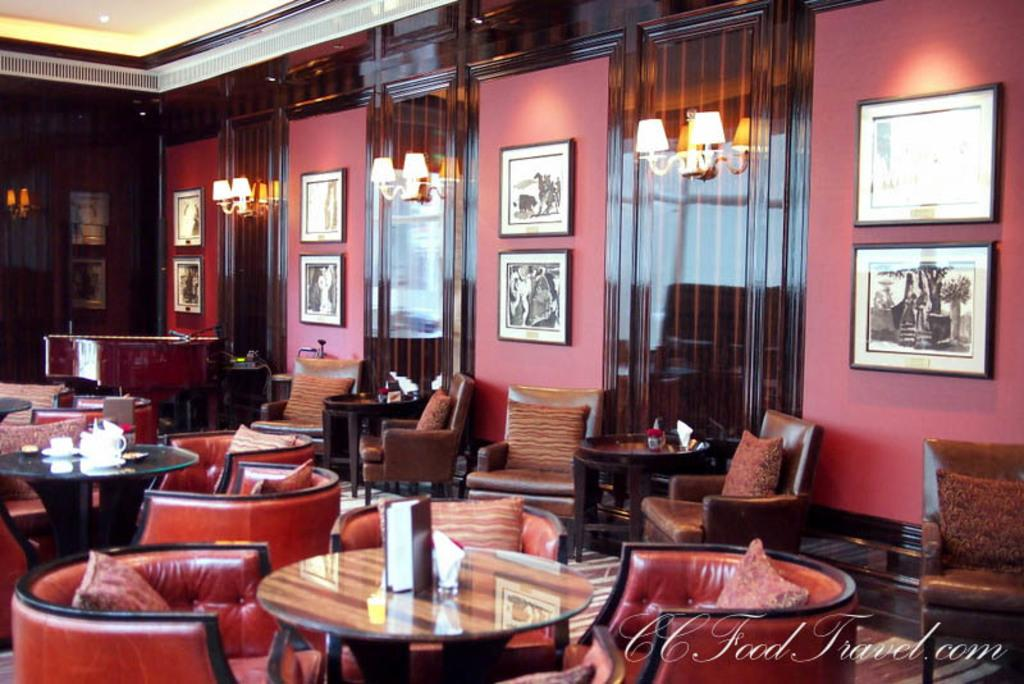What type of space is depicted in the image? There is a room in the image. What type of furniture is present in the room? There is a sofa set and chairs in the room. What items can be seen on the table in the room? There is a cup and a menu book on a table in the room. What can be seen in the background of the room? In the background, there is lighting, curtains, and photo frames. What type of destruction can be seen in the image? There is no destruction present in the image; it depicts a room with furniture and background elements. What type of pies are being served in the image? There is no mention of pies in the image; it only shows a cup and a menu book on a table. 